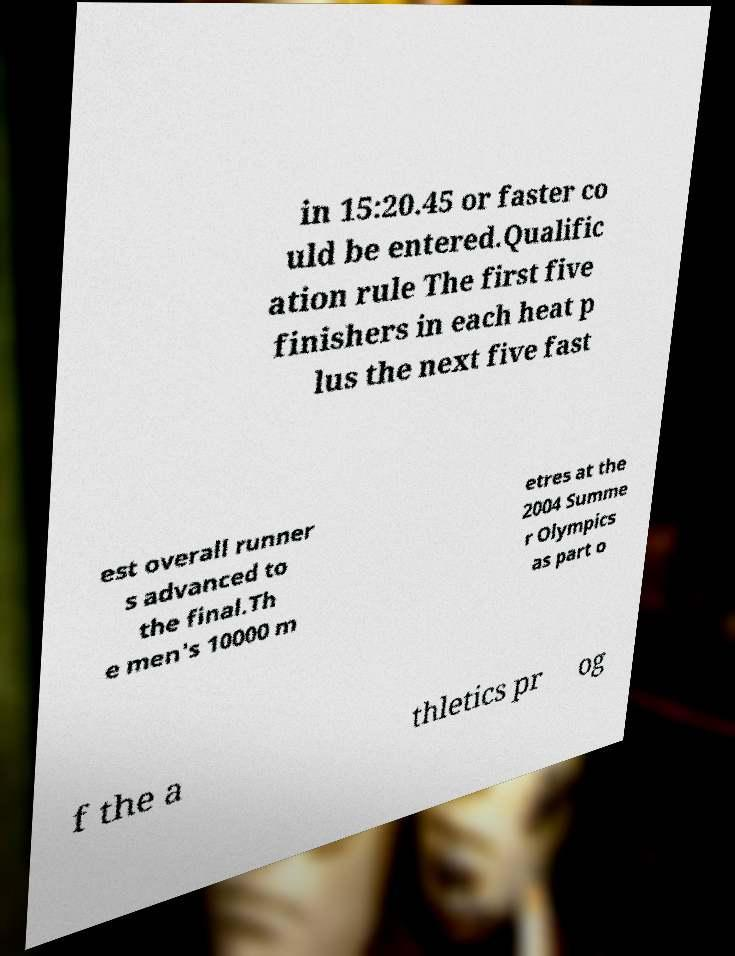What messages or text are displayed in this image? I need them in a readable, typed format. in 15:20.45 or faster co uld be entered.Qualific ation rule The first five finishers in each heat p lus the next five fast est overall runner s advanced to the final.Th e men's 10000 m etres at the 2004 Summe r Olympics as part o f the a thletics pr og 